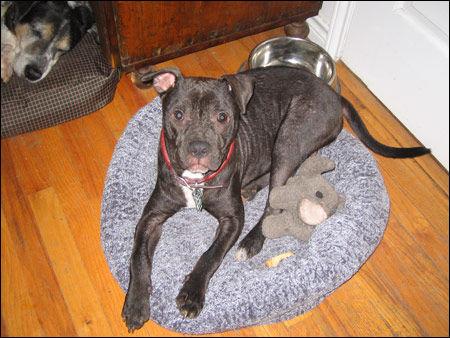How many dogs are sleeping?
Quick response, please. 1. What kind of animal is the dog toy?
Short answer required. Elephant. What color is the dog's leash?
Quick response, please. Red. 